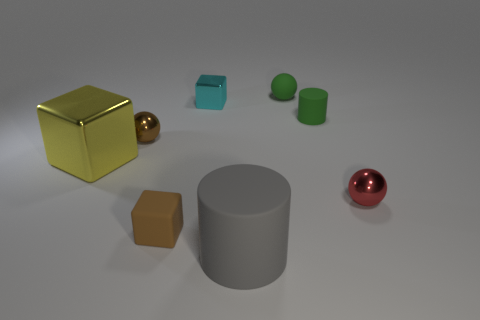Subtract all tiny blocks. How many blocks are left? 1 Subtract 1 cubes. How many cubes are left? 2 Subtract all red blocks. Subtract all purple cylinders. How many blocks are left? 3 Add 2 green matte cylinders. How many objects exist? 10 Subtract all cubes. How many objects are left? 5 Subtract 0 cyan balls. How many objects are left? 8 Subtract all big gray things. Subtract all tiny cyan things. How many objects are left? 6 Add 2 cyan shiny blocks. How many cyan shiny blocks are left? 3 Add 8 small red metallic balls. How many small red metallic balls exist? 9 